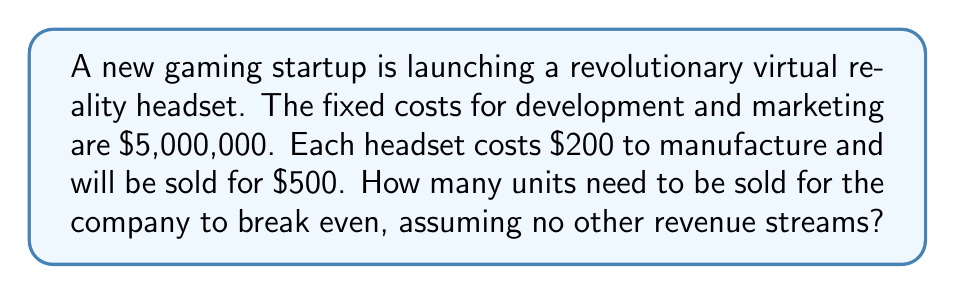Provide a solution to this math problem. To find the break-even point, we need to determine the number of units that need to be sold for the total revenue to equal the total costs. Let's break this down step-by-step:

1. Define variables:
   Let $x$ be the number of units sold
   Fixed costs (FC) = $5,000,000
   Variable cost per unit (VC) = $200
   Selling price per unit (P) = $500

2. Set up the break-even equation:
   Total Revenue = Total Costs
   $Px = FC + VCx$

3. Substitute the values:
   $500x = 5,000,000 + 200x$

4. Solve for $x$:
   $500x - 200x = 5,000,000$
   $300x = 5,000,000$
   
   $$x = \frac{5,000,000}{300} = 16,666.67$$

5. Since we can't sell a fraction of a unit, we round up to the nearest whole number.

The break-even point occurs when the company sells 16,667 units. At this point:

Total Revenue = $500 * 16,667 = $8,333,500
Total Costs = $5,000,000 + ($200 * 16,667) = $8,333,400

The slight difference is due to rounding, but this is the minimum number of units that need to be sold to break even.
Answer: 16,667 units 